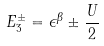Convert formula to latex. <formula><loc_0><loc_0><loc_500><loc_500>E _ { 3 } ^ { \pm } = \epsilon ^ { \beta } \pm \frac { U } { 2 }</formula> 